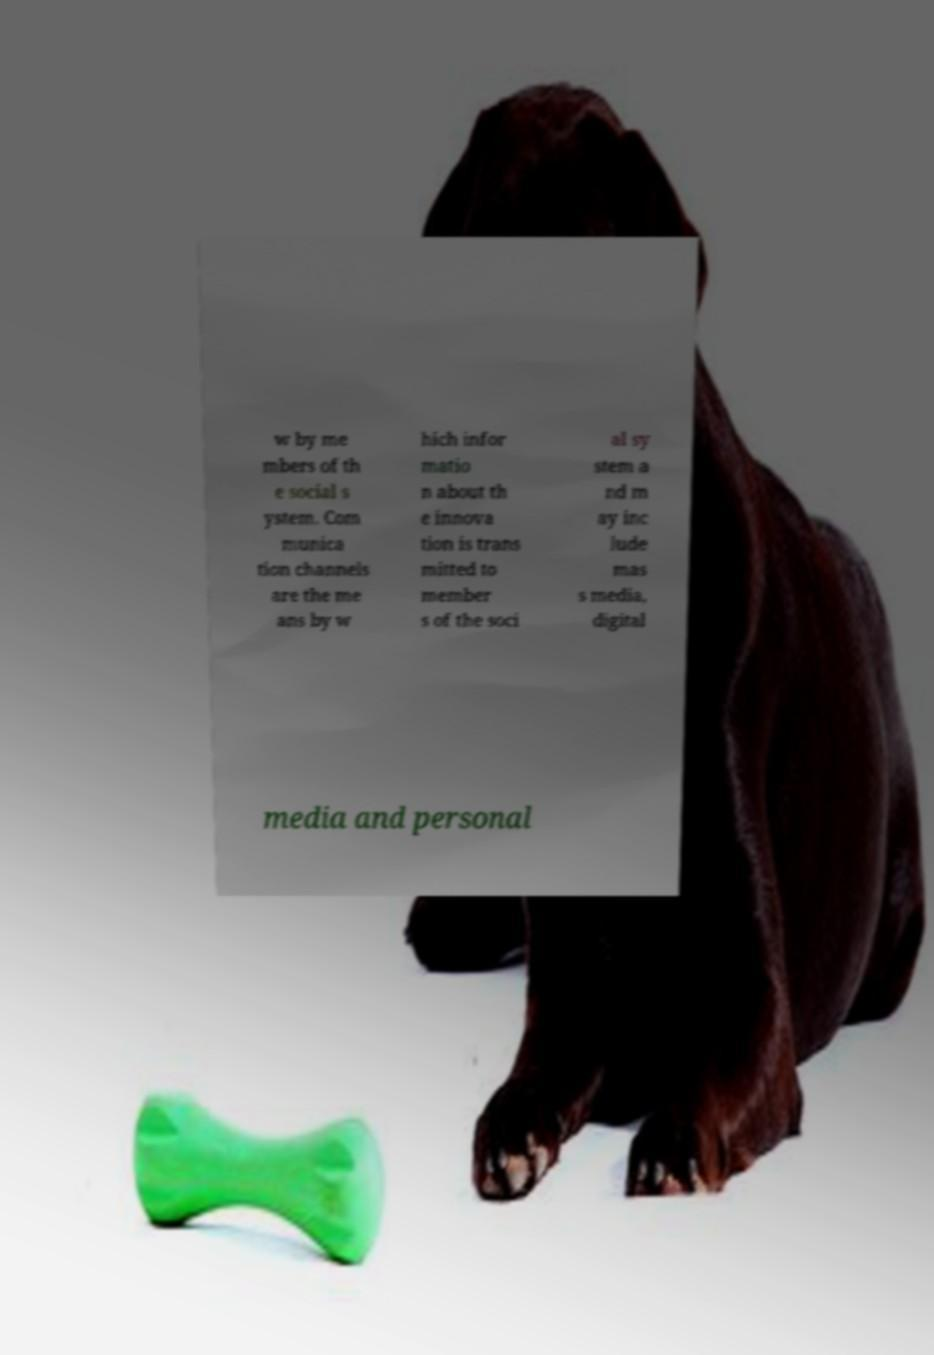Could you assist in decoding the text presented in this image and type it out clearly? w by me mbers of th e social s ystem. Com munica tion channels are the me ans by w hich infor matio n about th e innova tion is trans mitted to member s of the soci al sy stem a nd m ay inc lude mas s media, digital media and personal 